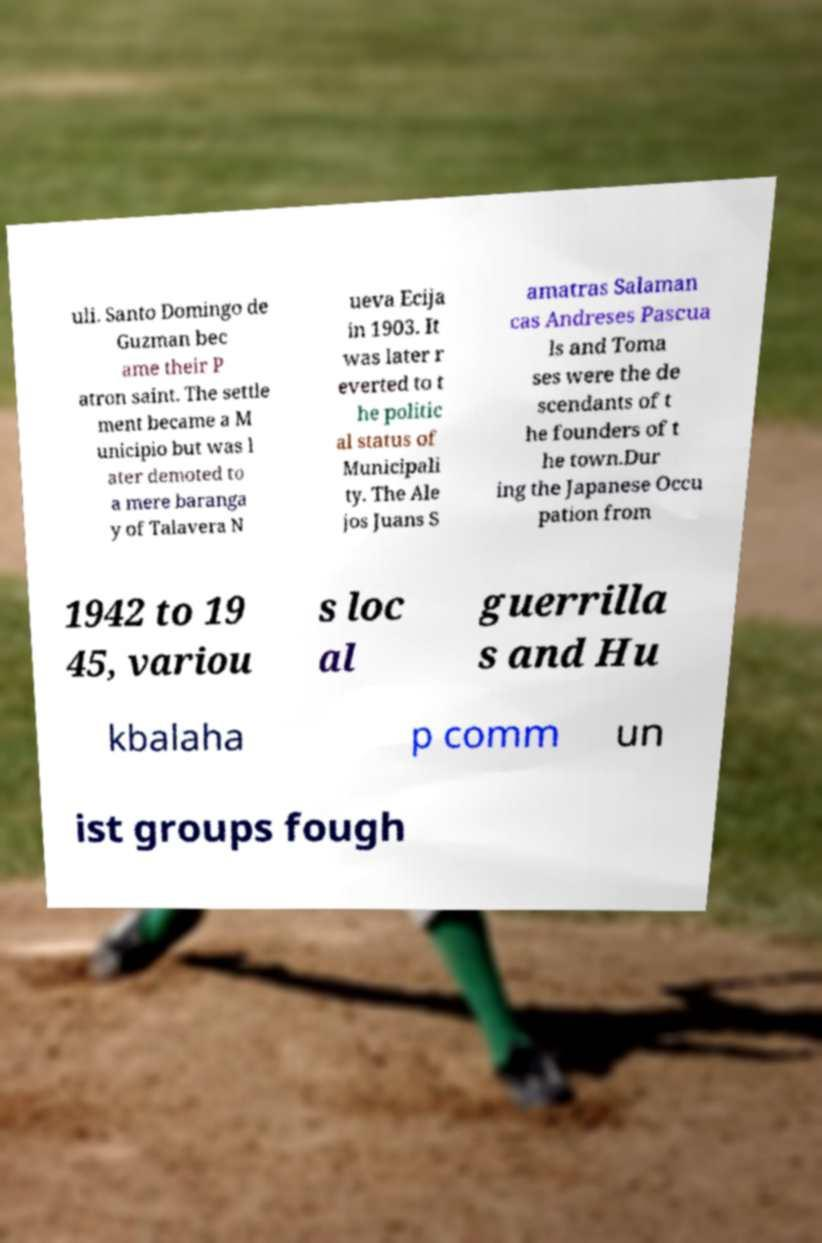What messages or text are displayed in this image? I need them in a readable, typed format. uli. Santo Domingo de Guzman bec ame their P atron saint. The settle ment became a M unicipio but was l ater demoted to a mere baranga y of Talavera N ueva Ecija in 1903. It was later r everted to t he politic al status of Municipali ty. The Ale jos Juans S amatras Salaman cas Andreses Pascua ls and Toma ses were the de scendants of t he founders of t he town.Dur ing the Japanese Occu pation from 1942 to 19 45, variou s loc al guerrilla s and Hu kbalaha p comm un ist groups fough 